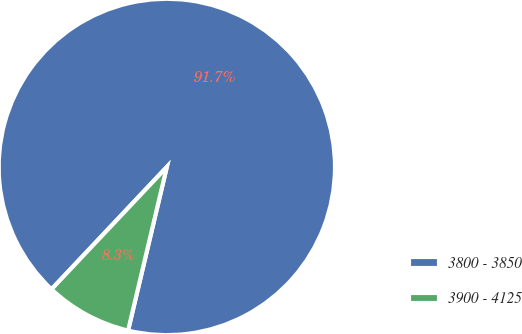Convert chart to OTSL. <chart><loc_0><loc_0><loc_500><loc_500><pie_chart><fcel>3800 - 3850<fcel>3900 - 4125<nl><fcel>91.67%<fcel>8.33%<nl></chart> 